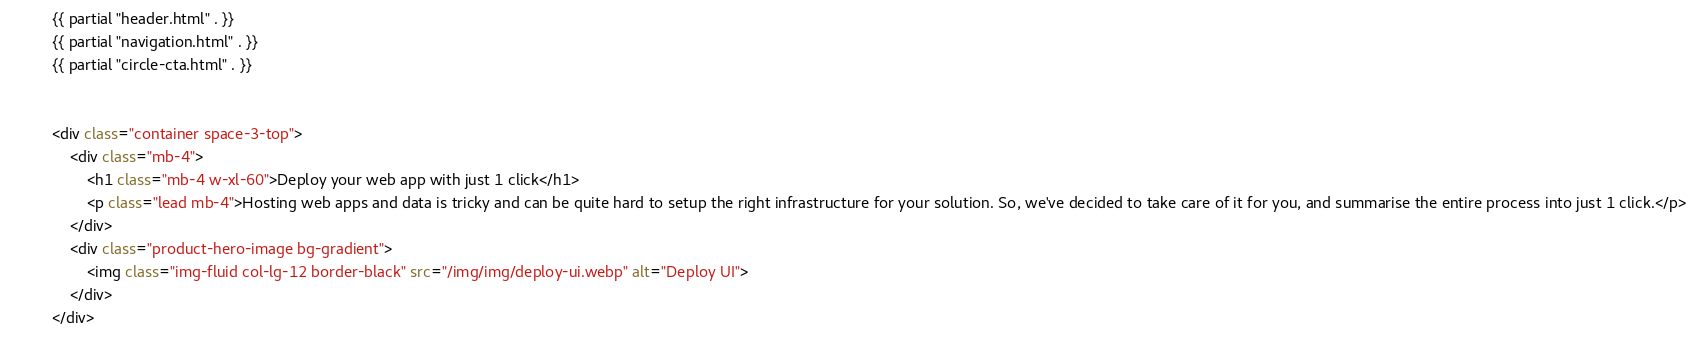<code> <loc_0><loc_0><loc_500><loc_500><_HTML_>{{ partial "header.html" . }}
{{ partial "navigation.html" . }}
{{ partial "circle-cta.html" . }}


<div class="container space-3-top">
    <div class="mb-4">
        <h1 class="mb-4 w-xl-60">Deploy your web app with just 1 click</h1>
        <p class="lead mb-4">Hosting web apps and data is tricky and can be quite hard to setup the right infrastructure for your solution. So, we've decided to take care of it for you, and summarise the entire process into just 1 click.</p>
    </div>
    <div class="product-hero-image bg-gradient">
        <img class="img-fluid col-lg-12 border-black" src="/img/img/deploy-ui.webp" alt="Deploy UI">
    </div>
</div>
</code> 